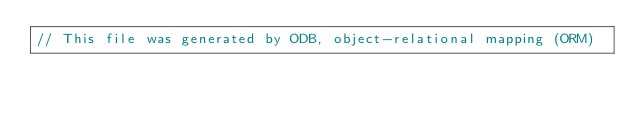<code> <loc_0><loc_0><loc_500><loc_500><_C_>// This file was generated by ODB, object-relational mapping (ORM)</code> 